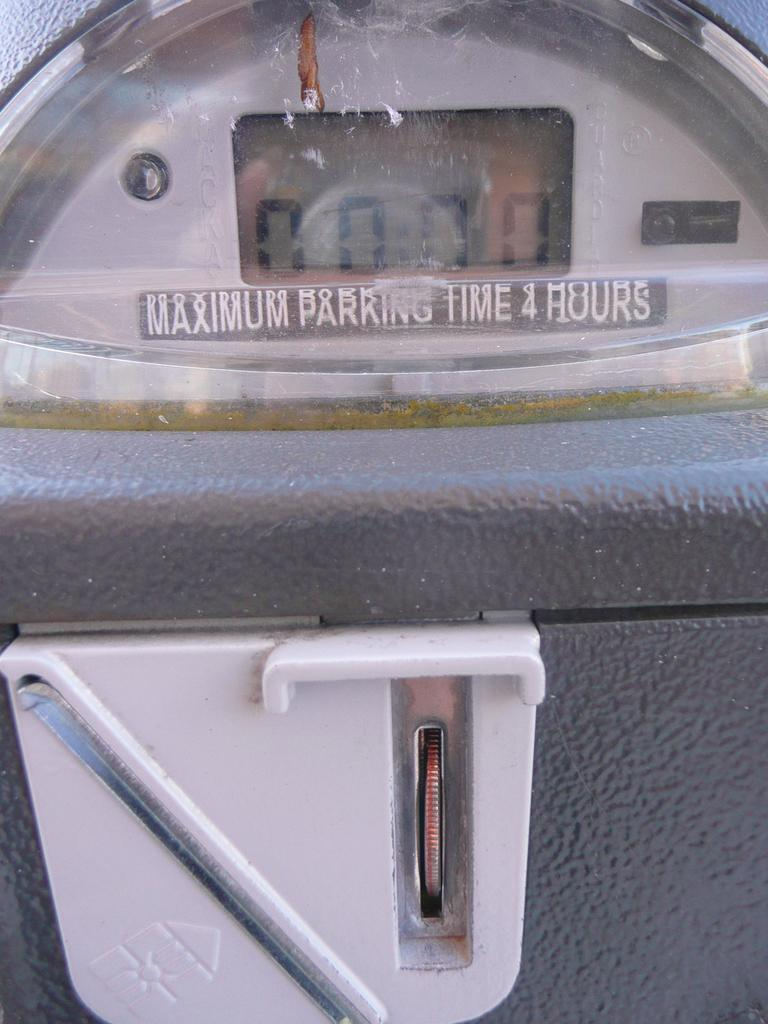What is the main subject in the image? There is a digital meter in the image. What type of fruit is hanging from the digital meter in the image? There is no fruit present in the image, as it features a digital meter. 